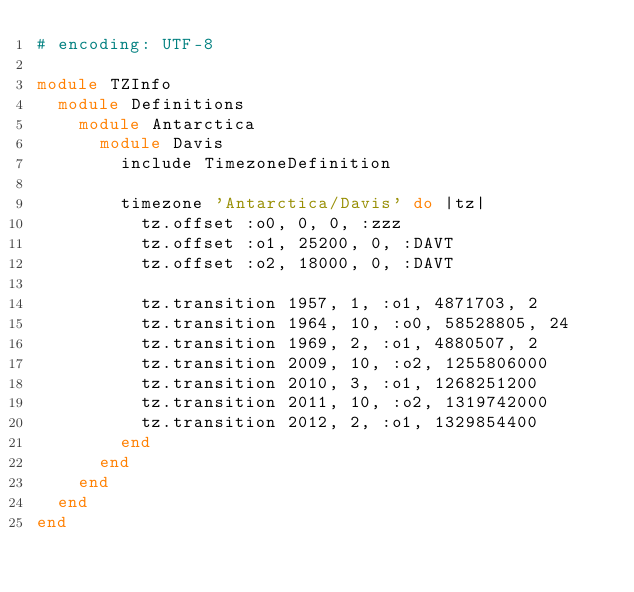<code> <loc_0><loc_0><loc_500><loc_500><_Ruby_># encoding: UTF-8

module TZInfo
  module Definitions
    module Antarctica
      module Davis
        include TimezoneDefinition
        
        timezone 'Antarctica/Davis' do |tz|
          tz.offset :o0, 0, 0, :zzz
          tz.offset :o1, 25200, 0, :DAVT
          tz.offset :o2, 18000, 0, :DAVT
          
          tz.transition 1957, 1, :o1, 4871703, 2
          tz.transition 1964, 10, :o0, 58528805, 24
          tz.transition 1969, 2, :o1, 4880507, 2
          tz.transition 2009, 10, :o2, 1255806000
          tz.transition 2010, 3, :o1, 1268251200
          tz.transition 2011, 10, :o2, 1319742000
          tz.transition 2012, 2, :o1, 1329854400
        end
      end
    end
  end
end
</code> 